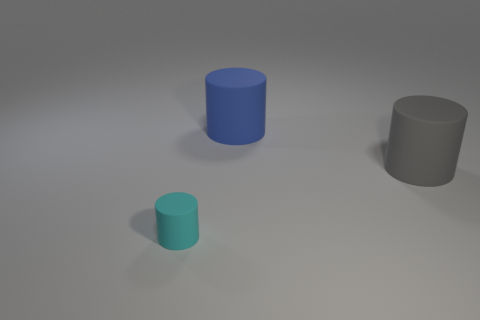How many other things are there of the same size as the blue rubber thing?
Offer a terse response. 1. Are there any other things that are the same size as the gray cylinder?
Give a very brief answer. Yes. How many other objects are there of the same shape as the large blue thing?
Ensure brevity in your answer.  2. Is the cyan matte cylinder the same size as the blue rubber cylinder?
Provide a short and direct response. No. Is there a large blue rubber object?
Offer a very short reply. Yes. Is there anything else that has the same material as the cyan object?
Offer a terse response. Yes. Is there a large yellow object made of the same material as the big gray object?
Give a very brief answer. No. There is a gray thing that is the same size as the blue matte cylinder; what is its material?
Keep it short and to the point. Rubber. How many big metal objects have the same shape as the large blue rubber object?
Keep it short and to the point. 0. What size is the blue cylinder that is the same material as the small thing?
Provide a short and direct response. Large. 